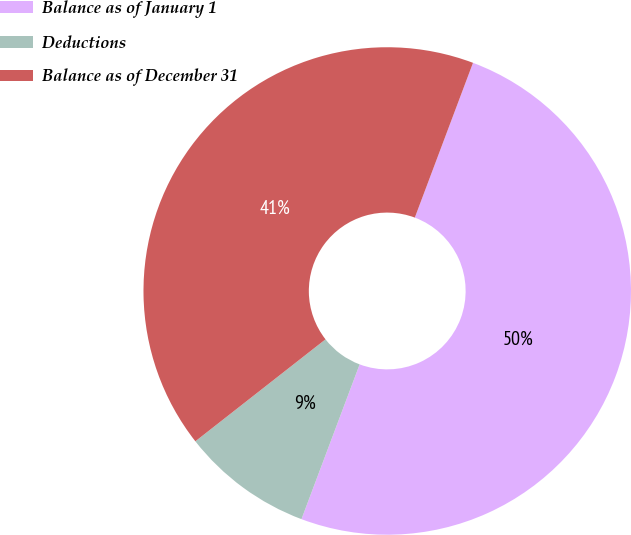<chart> <loc_0><loc_0><loc_500><loc_500><pie_chart><fcel>Balance as of January 1<fcel>Deductions<fcel>Balance as of December 31<nl><fcel>50.0%<fcel>8.7%<fcel>41.3%<nl></chart> 